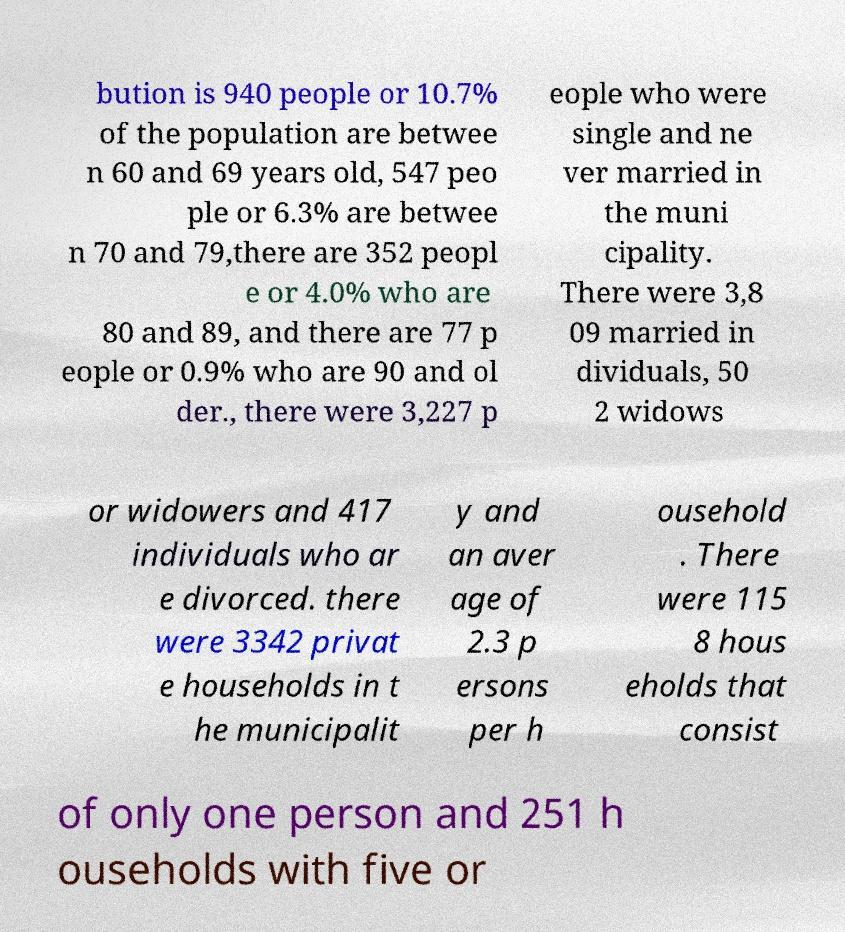What messages or text are displayed in this image? I need them in a readable, typed format. bution is 940 people or 10.7% of the population are betwee n 60 and 69 years old, 547 peo ple or 6.3% are betwee n 70 and 79,there are 352 peopl e or 4.0% who are 80 and 89, and there are 77 p eople or 0.9% who are 90 and ol der., there were 3,227 p eople who were single and ne ver married in the muni cipality. There were 3,8 09 married in dividuals, 50 2 widows or widowers and 417 individuals who ar e divorced. there were 3342 privat e households in t he municipalit y and an aver age of 2.3 p ersons per h ousehold . There were 115 8 hous eholds that consist of only one person and 251 h ouseholds with five or 